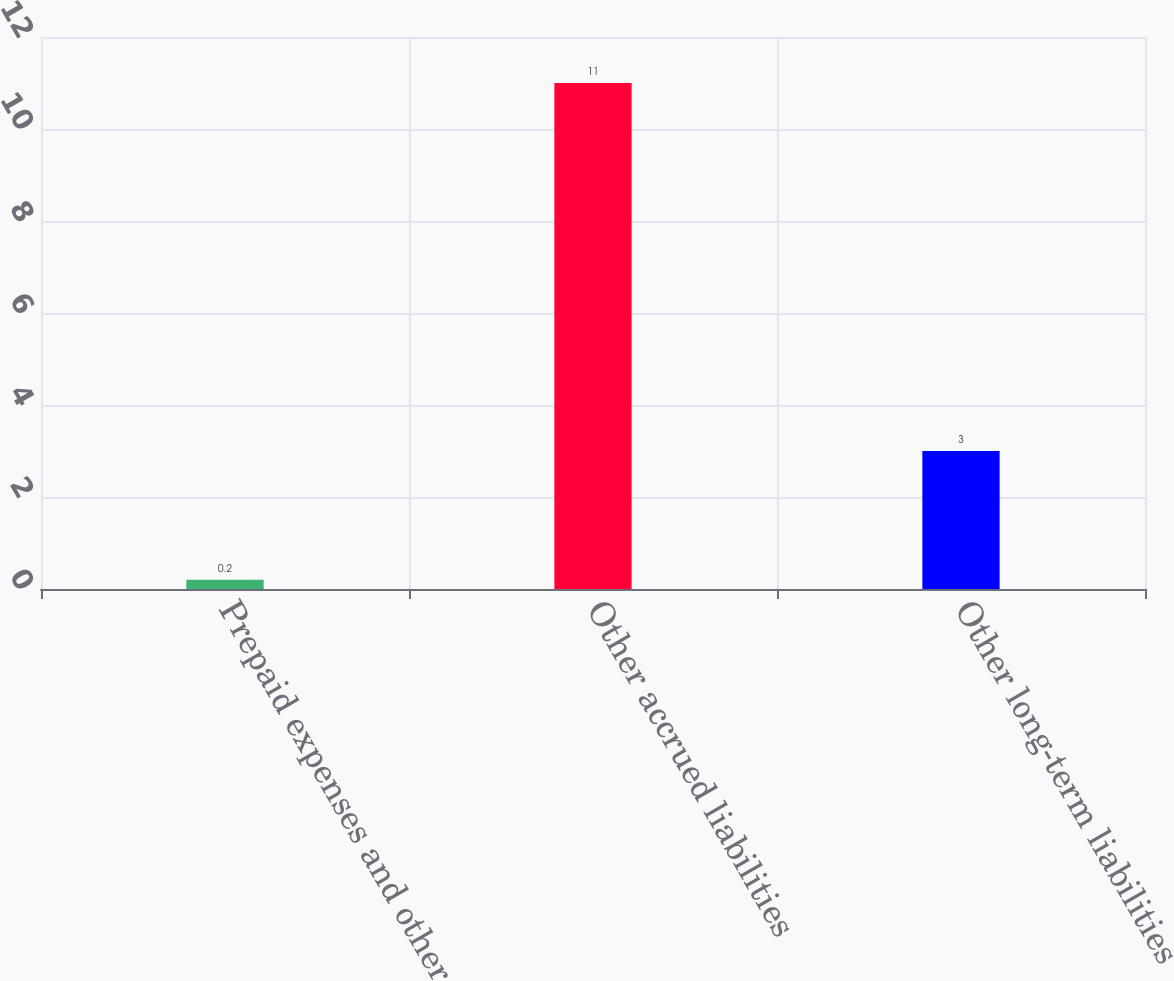<chart> <loc_0><loc_0><loc_500><loc_500><bar_chart><fcel>Prepaid expenses and other<fcel>Other accrued liabilities<fcel>Other long-term liabilities<nl><fcel>0.2<fcel>11<fcel>3<nl></chart> 